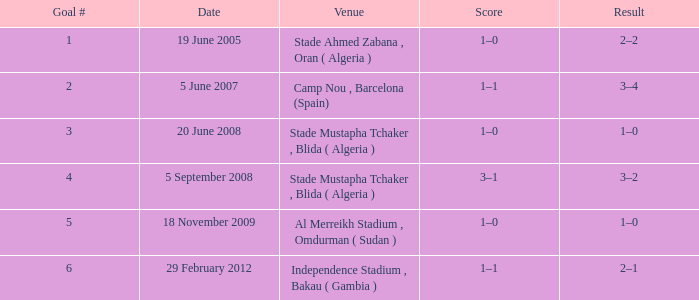What was the location where goal #2 took place? Camp Nou , Barcelona (Spain). Would you mind parsing the complete table? {'header': ['Goal #', 'Date', 'Venue', 'Score', 'Result'], 'rows': [['1', '19 June 2005', 'Stade Ahmed Zabana , Oran ( Algeria )', '1–0', '2–2'], ['2', '5 June 2007', 'Camp Nou , Barcelona (Spain)', '1–1', '3–4'], ['3', '20 June 2008', 'Stade Mustapha Tchaker , Blida ( Algeria )', '1–0', '1–0'], ['4', '5 September 2008', 'Stade Mustapha Tchaker , Blida ( Algeria )', '3–1', '3–2'], ['5', '18 November 2009', 'Al Merreikh Stadium , Omdurman ( Sudan )', '1–0', '1–0'], ['6', '29 February 2012', 'Independence Stadium , Bakau ( Gambia )', '1–1', '2–1']]} 